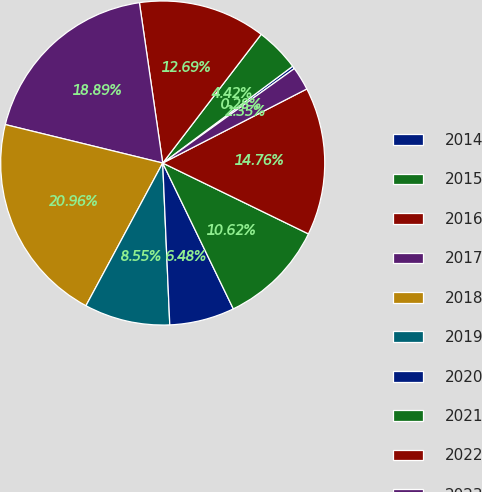<chart> <loc_0><loc_0><loc_500><loc_500><pie_chart><fcel>2014<fcel>2015<fcel>2016<fcel>2017<fcel>2018<fcel>2019<fcel>2020<fcel>2021<fcel>2022<fcel>2023<nl><fcel>0.28%<fcel>4.42%<fcel>12.69%<fcel>18.89%<fcel>20.96%<fcel>8.55%<fcel>6.48%<fcel>10.62%<fcel>14.76%<fcel>2.35%<nl></chart> 